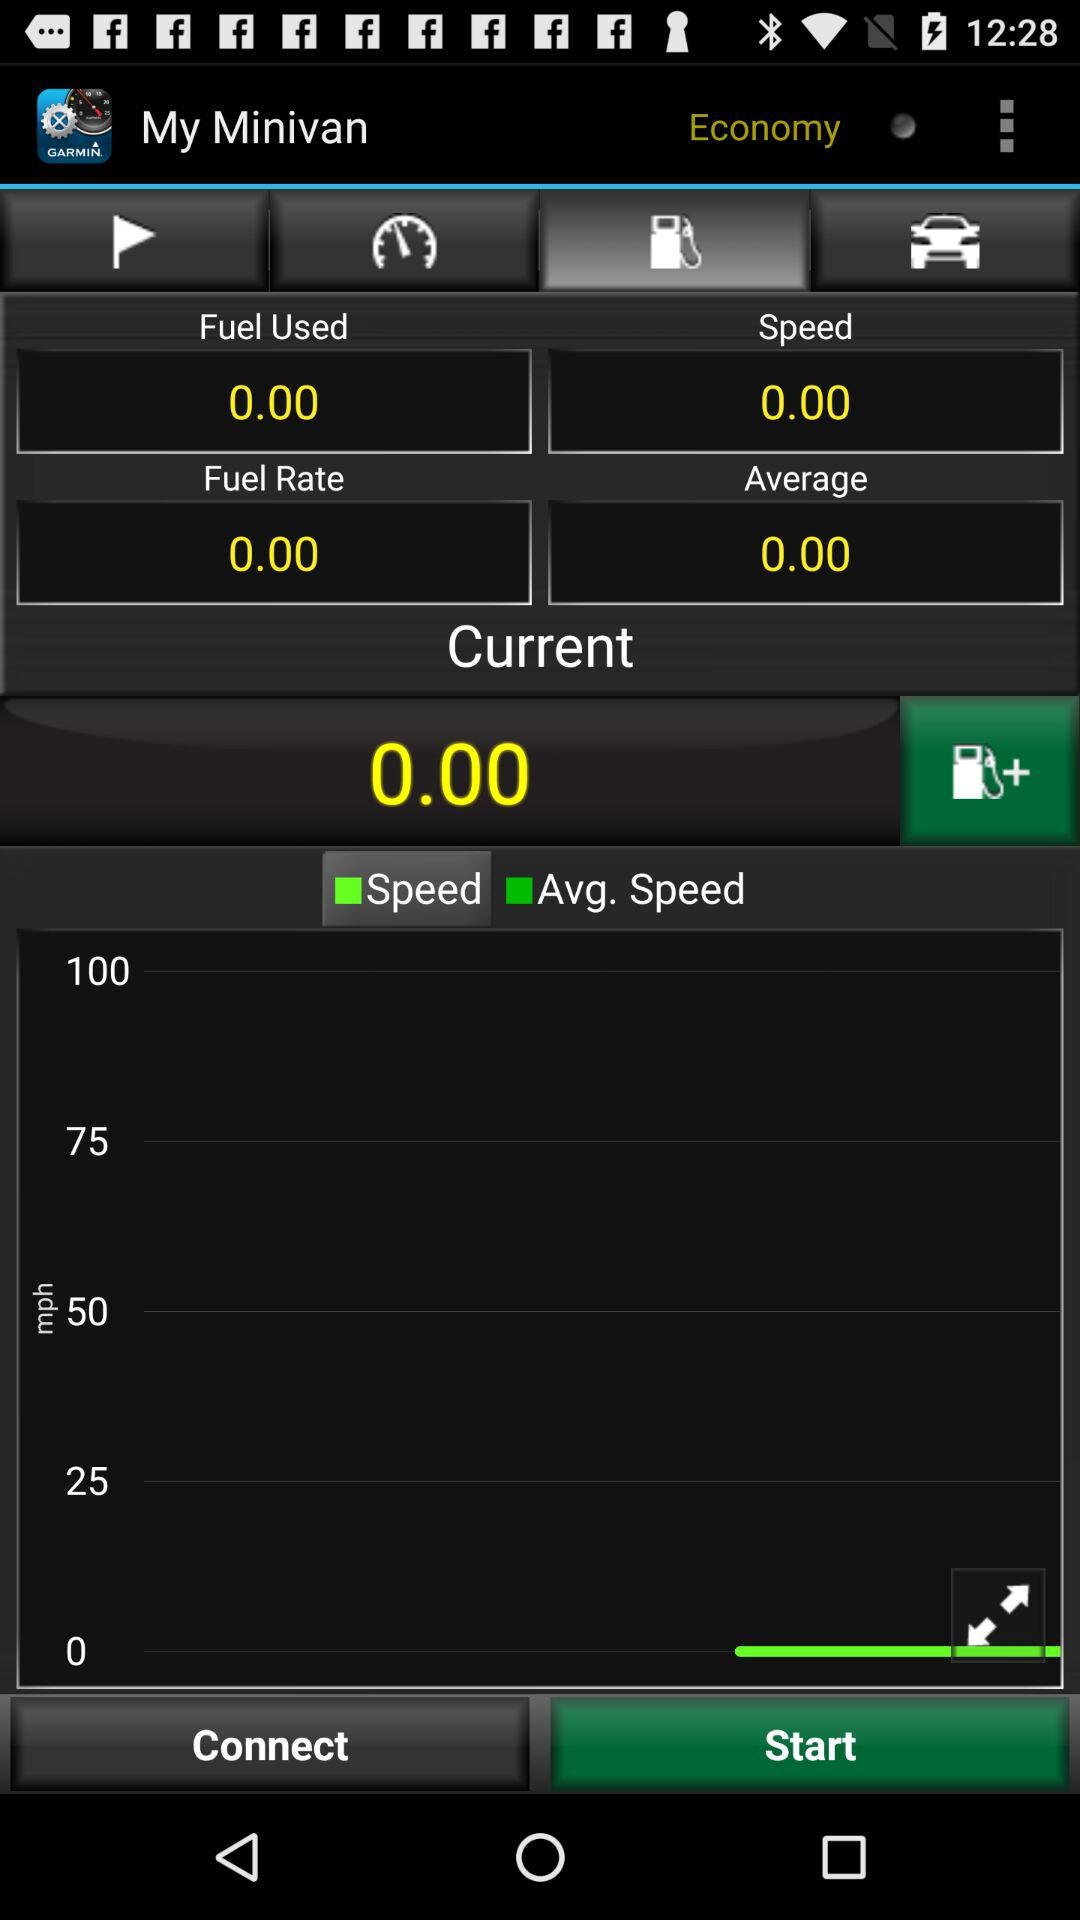What is the average? The average is 0.00. 